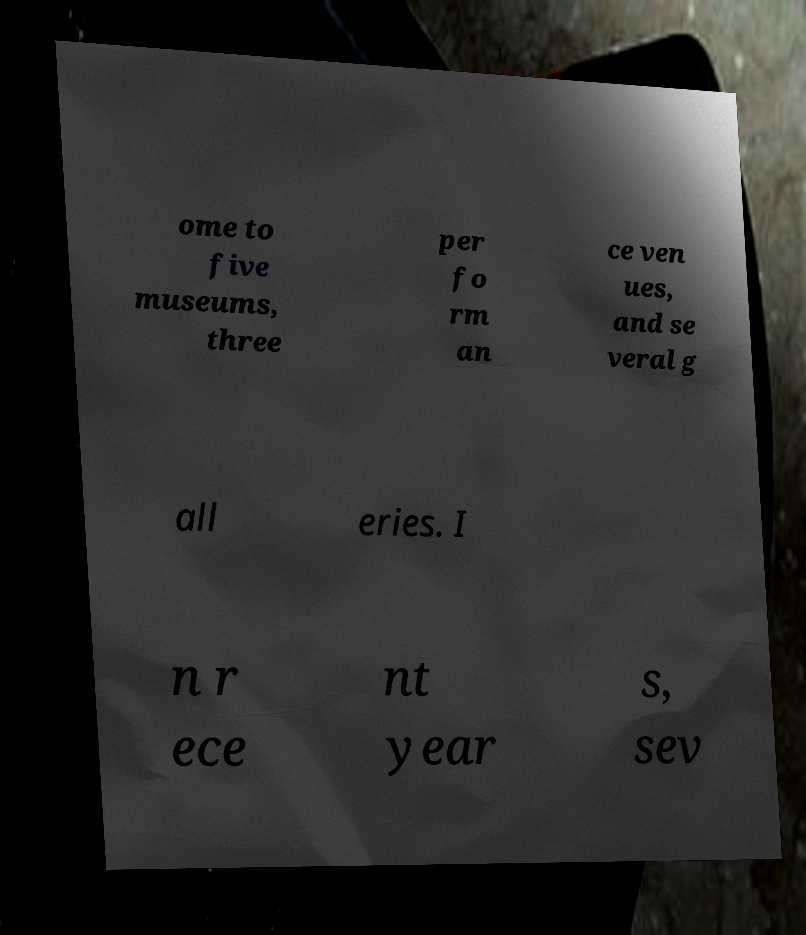There's text embedded in this image that I need extracted. Can you transcribe it verbatim? ome to five museums, three per fo rm an ce ven ues, and se veral g all eries. I n r ece nt year s, sev 